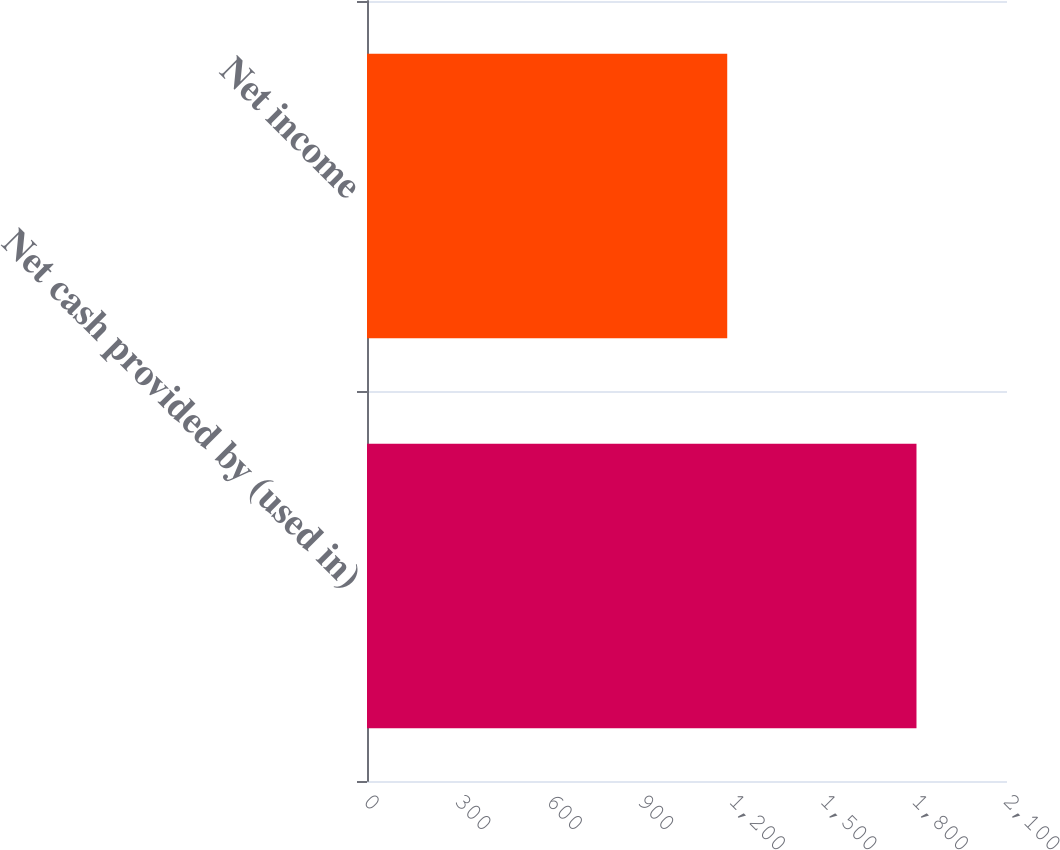Convert chart. <chart><loc_0><loc_0><loc_500><loc_500><bar_chart><fcel>Net cash provided by (used in)<fcel>Net income<nl><fcel>1803<fcel>1182<nl></chart> 